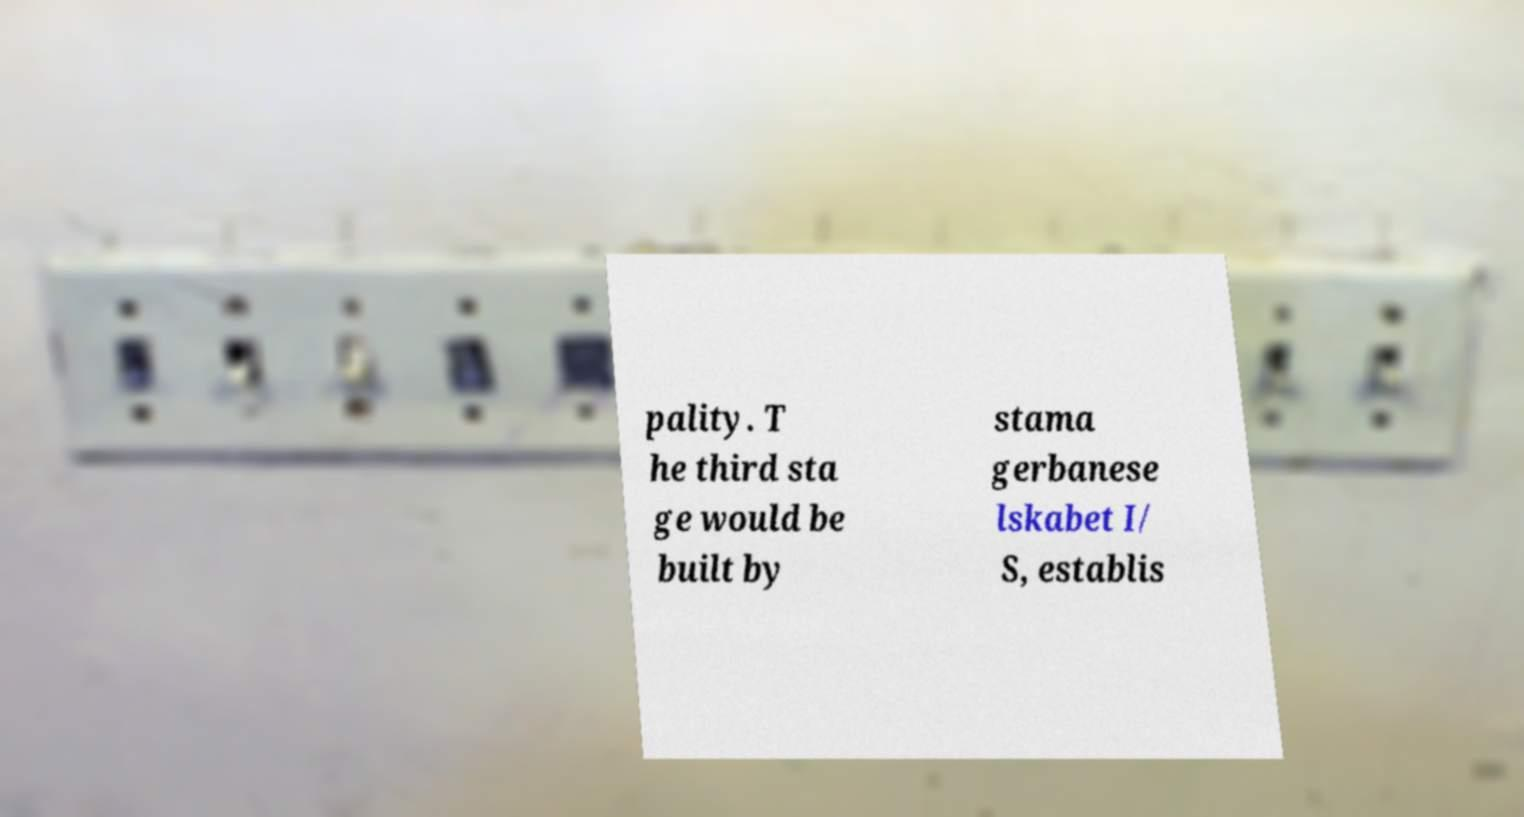Could you extract and type out the text from this image? pality. T he third sta ge would be built by stama gerbanese lskabet I/ S, establis 